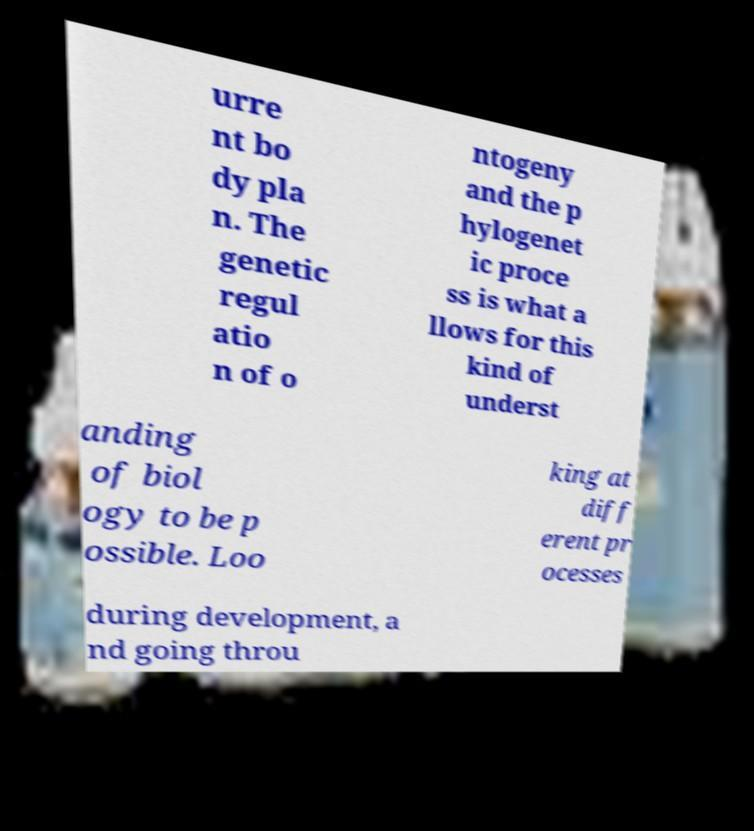Could you extract and type out the text from this image? urre nt bo dy pla n. The genetic regul atio n of o ntogeny and the p hylogenet ic proce ss is what a llows for this kind of underst anding of biol ogy to be p ossible. Loo king at diff erent pr ocesses during development, a nd going throu 